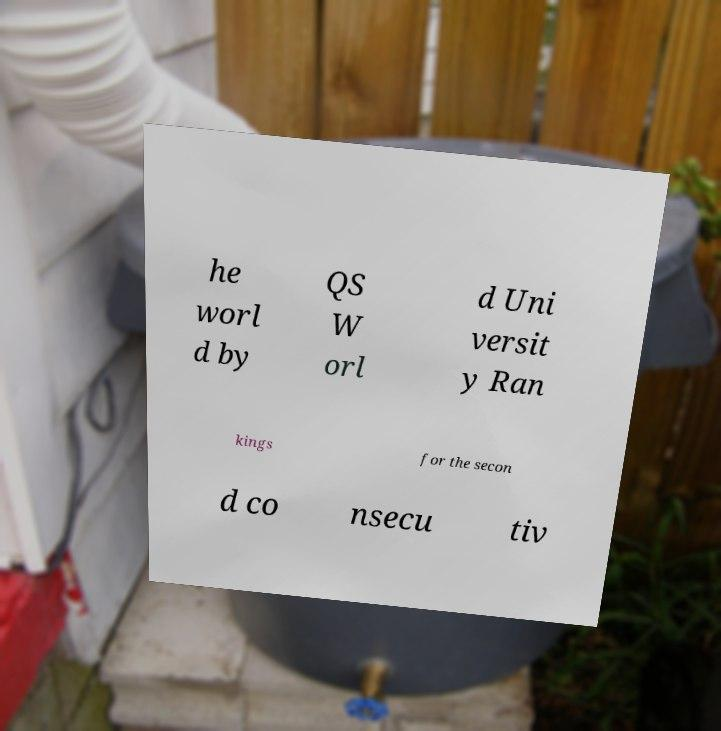For documentation purposes, I need the text within this image transcribed. Could you provide that? he worl d by QS W orl d Uni versit y Ran kings for the secon d co nsecu tiv 